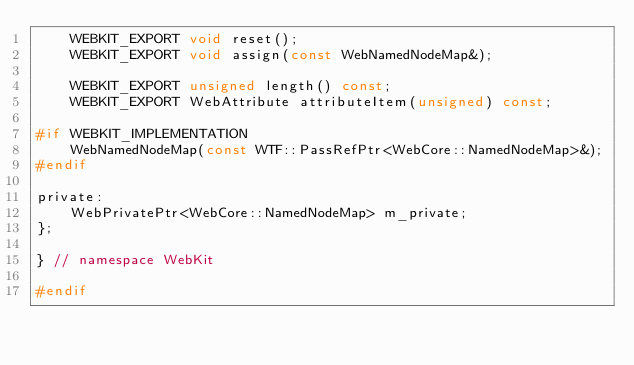Convert code to text. <code><loc_0><loc_0><loc_500><loc_500><_C_>    WEBKIT_EXPORT void reset();
    WEBKIT_EXPORT void assign(const WebNamedNodeMap&);

    WEBKIT_EXPORT unsigned length() const;
    WEBKIT_EXPORT WebAttribute attributeItem(unsigned) const;

#if WEBKIT_IMPLEMENTATION
    WebNamedNodeMap(const WTF::PassRefPtr<WebCore::NamedNodeMap>&);
#endif

private:
    WebPrivatePtr<WebCore::NamedNodeMap> m_private;
};

} // namespace WebKit

#endif
</code> 